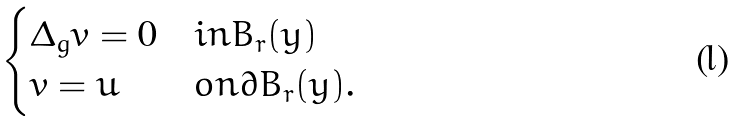<formula> <loc_0><loc_0><loc_500><loc_500>\begin{cases} \Delta _ { g } v = 0 & i n B _ { r } ( y ) \\ v = u & o n \partial { B } _ { r } ( y ) . \end{cases}</formula> 